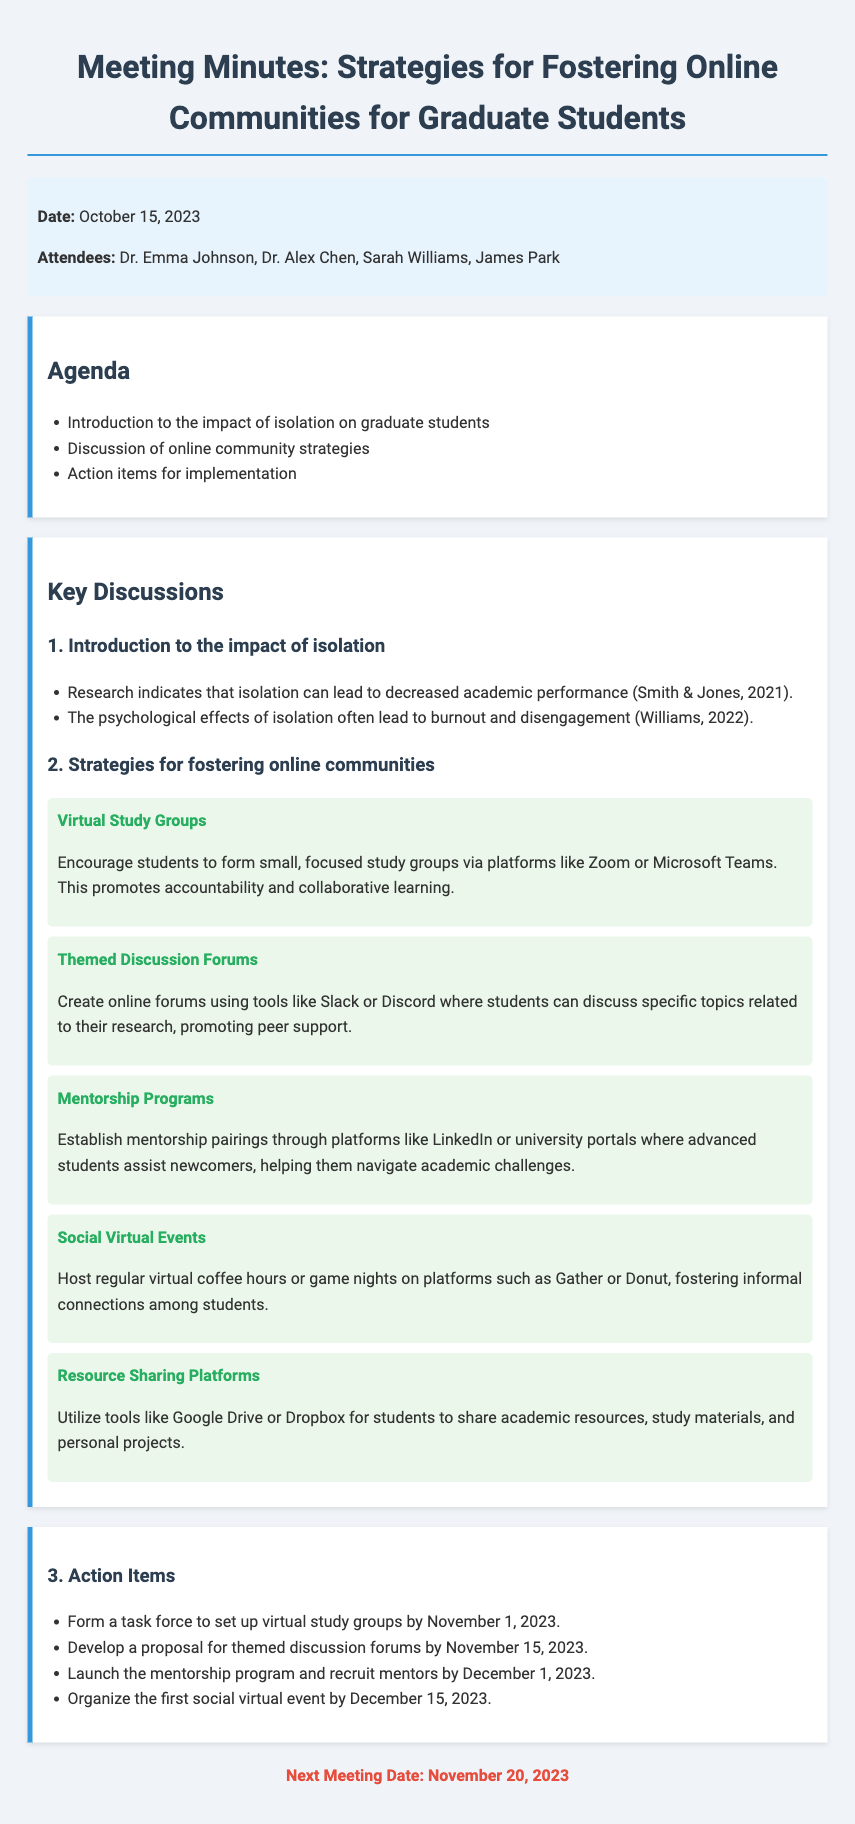what is the date of the meeting? The date is explicitly mentioned in the meta-info section of the document.
Answer: October 15, 2023 who are the attendees of the meeting? The attendees are listed in the meta-info section, providing names of all participants.
Answer: Dr. Emma Johnson, Dr. Alex Chen, Sarah Williams, James Park what strategy involves students forming small study groups? This strategy is categorized under "Strategies for fostering online communities" in the key discussions section.
Answer: Virtual Study Groups when is the next meeting scheduled? The next meeting date is provided at the end of the document as a part of the summary.
Answer: November 20, 2023 how many action items were discussed? The number of action items can be counted from the action items section in the document.
Answer: Four what platform is suggested for the mentorship program? The document specifies a platform that can be used for mentorship pairings.
Answer: LinkedIn what type of events are proposed to foster informal connections? This type of event is detailed under the strategies section of the key discussions.
Answer: Social Virtual Events what is one of the negative impacts of isolation mentioned? The document refers to the psychological effects associated with isolation.
Answer: Burnout 